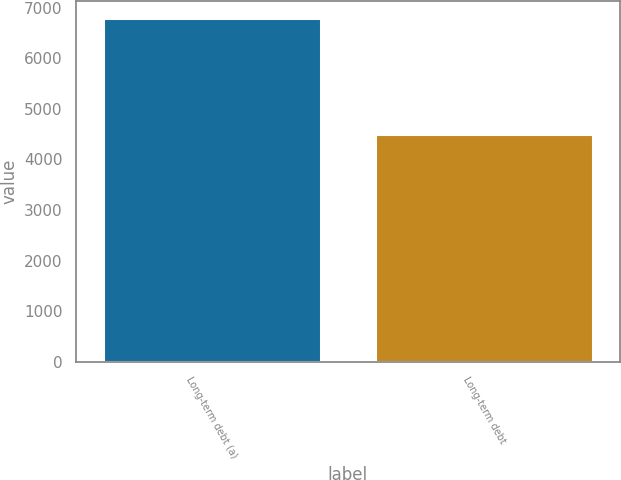Convert chart to OTSL. <chart><loc_0><loc_0><loc_500><loc_500><bar_chart><fcel>Long-term debt (a)<fcel>Long-term debt<nl><fcel>6785<fcel>4507<nl></chart> 